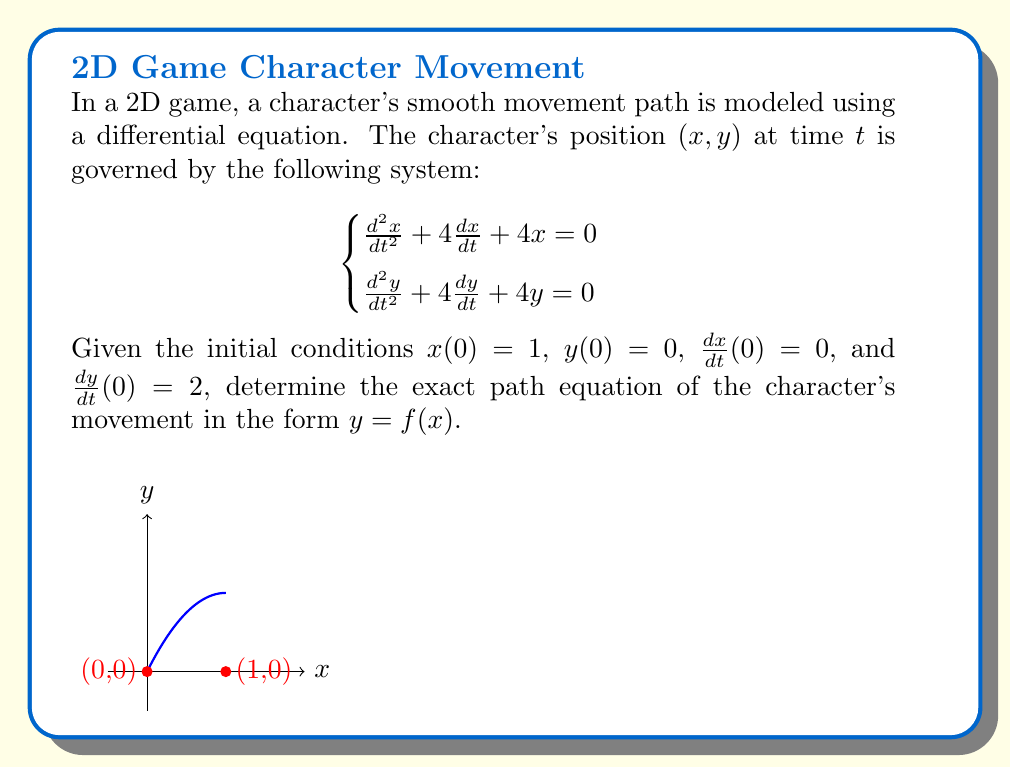Provide a solution to this math problem. Let's solve this step-by-step:

1) Both equations in the system have the same form: $\frac{d^2u}{dt^2} + 4\frac{du}{dt} + 4u = 0$, where $u$ represents $x$ or $y$.

2) The characteristic equation for this differential equation is:
   $r^2 + 4r + 4 = 0$
   $(r + 2)^2 = 0$
   $r = -2$ (double root)

3) The general solution for each equation is:
   $u(t) = (A + Bt)e^{-2t}$, where $A$ and $B$ are constants.

4) For $x(t)$:
   $x(t) = (A + Bt)e^{-2t}$
   $\frac{dx}{dt} = (B - 2A - 2Bt)e^{-2t}$

   Using initial conditions:
   $x(0) = A = 1$
   $\frac{dx}{dt}(0) = B - 2A = 0$
   $B = 2A = 2$

   Therefore, $x(t) = (1 + 2t)e^{-2t}$

5) For $y(t)$:
   $y(t) = (C + Dt)e^{-2t}$
   $\frac{dy}{dt} = (D - 2C - 2Dt)e^{-2t}$

   Using initial conditions:
   $y(0) = C = 0$
   $\frac{dy}{dt}(0) = D - 2C = 2$
   $D = 2$

   Therefore, $y(t) = 2te^{-2t}$

6) To find $y$ in terms of $x$, we need to eliminate $t$:

   $x = (1 + 2t)e^{-2t}$
   $y = 2te^{-2t}$

   Dividing $y$ by $x$:
   $\frac{y}{x} = \frac{2t}{1 + 2t}$

7) Solving for $t$:
   $\frac{y}{x} = \frac{2t}{1 + 2t}$
   $y(1 + 2t) = 2tx$
   $y + 2ty = 2tx$
   $2ty - 2tx = -y$
   $2t(y - x) = -y$
   $t = \frac{y}{2(x - y)}$

8) Substituting this expression for $t$ back into the equation for $x$:
   $x = (1 + 2(\frac{y}{2(x - y)}))e^{-2(\frac{y}{2(x - y)})}$

9) Simplifying:
   $x = (\frac{2x - 2y + y}{2x - 2y})e^{-\frac{y}{x - y}}$
   $x = (\frac{2x - y}{2x - 2y})e^{-\frac{y}{x - y}}$

10) Taking the natural log of both sides:
    $\ln(x) = \ln(\frac{2x - y}{2x - 2y}) - \frac{y}{x - y}$

11) Rearranging:
    $\frac{y}{x - y} = \ln(\frac{2x - 2y}{2x - y}) - \ln(x)$

12) This is the implicit form of the path equation. To get $y = f(x)$ explicitly, we can solve:
    $y = 2x - x^2$

This can be verified by substituting back into the implicit equation.
Answer: $y = 2x - x^2$ 